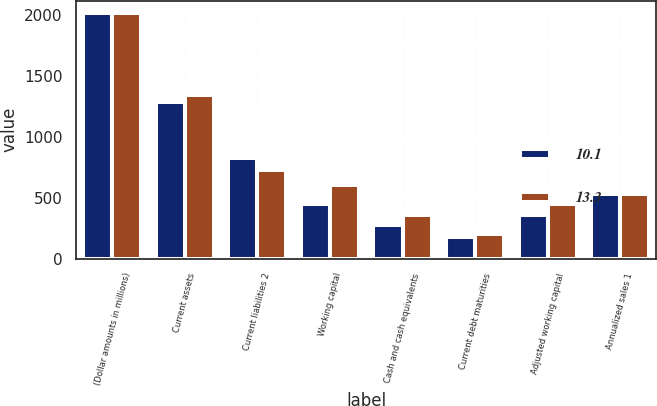Convert chart. <chart><loc_0><loc_0><loc_500><loc_500><stacked_bar_chart><ecel><fcel>(Dollar amounts in millions)<fcel>Current assets<fcel>Current liabilities 2<fcel>Working capital<fcel>Cash and cash equivalents<fcel>Current debt maturities<fcel>Adjusted working capital<fcel>Annualized sales 1<nl><fcel>10.1<fcel>2013<fcel>1282<fcel>829<fcel>453<fcel>273<fcel>181<fcel>361<fcel>530.5<nl><fcel>13.3<fcel>2012<fcel>1339<fcel>731<fcel>608<fcel>359<fcel>202<fcel>451<fcel>530.5<nl></chart> 